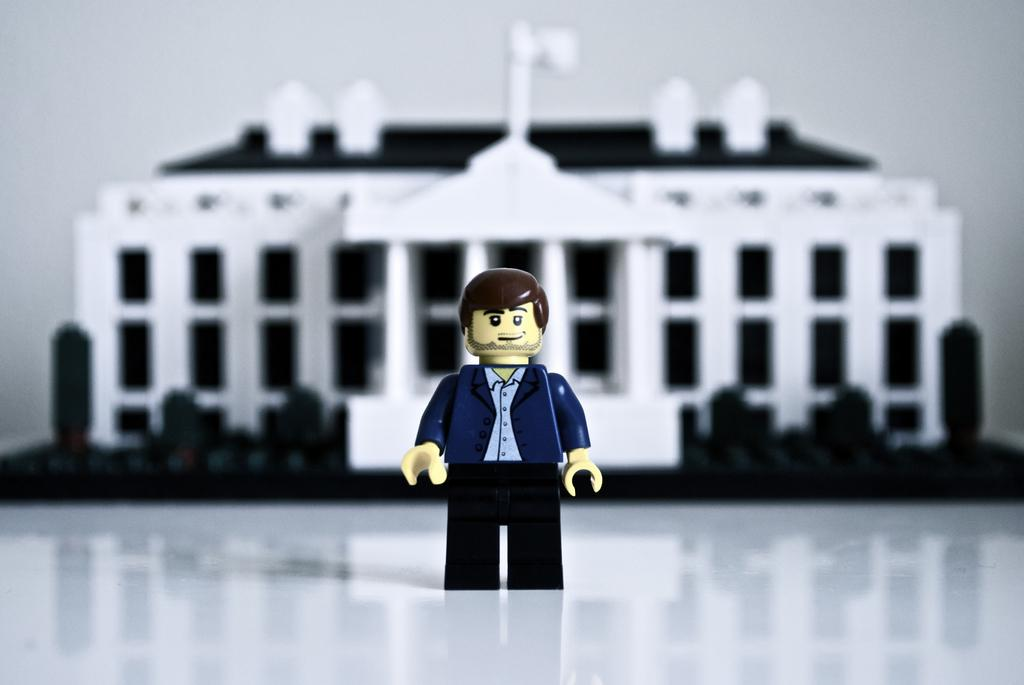What is the main subject of the image? There is a puppet in the image. What else can be seen in the image besides the puppet? There is a building in the image. Is the puppet wearing a vest while driving a car in the image? There is no car, driving, or vest present in the image. The image features a puppet and a building. 